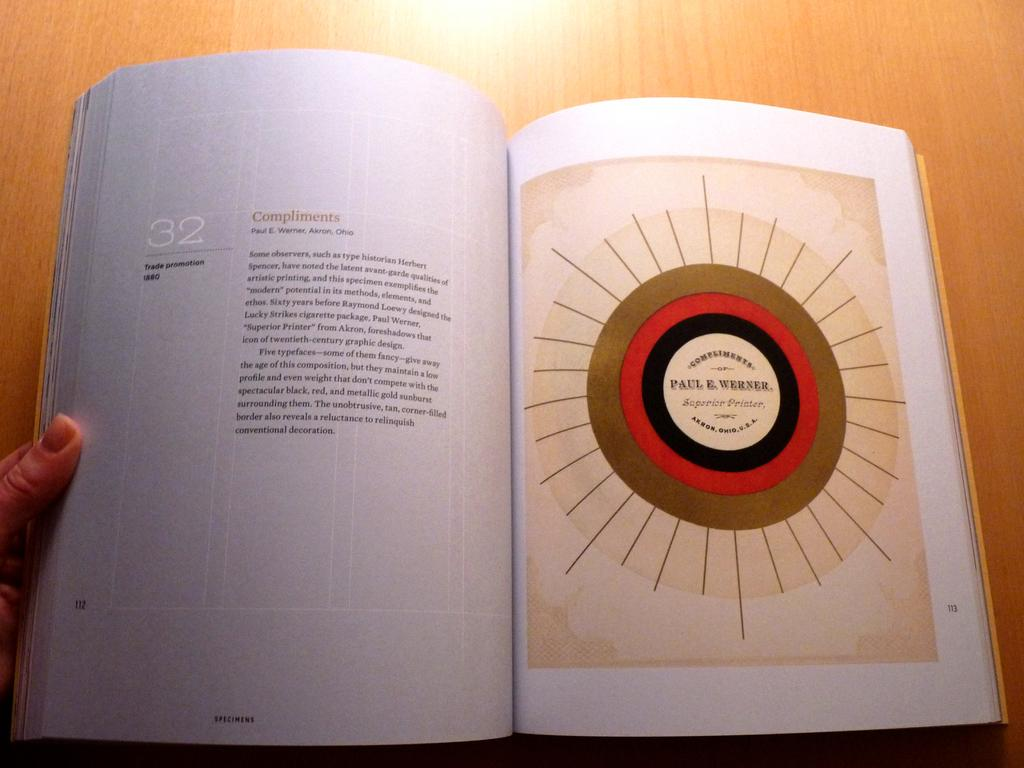<image>
Create a compact narrative representing the image presented. A book is opened with an illustration on the right and the number 32 on the left side. 